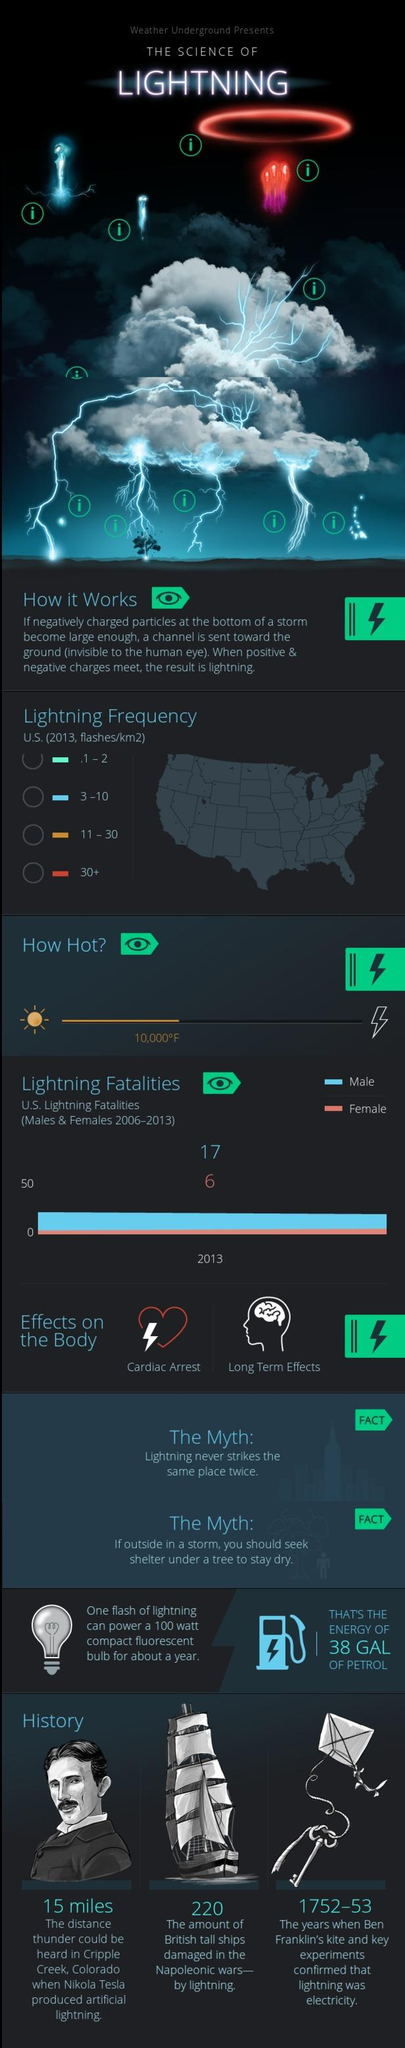Identify some key points in this picture. During the period of 2006-2013, more men died as a result of lightning than women. Specifically, 11 more men died due to lightning during this time frame. 